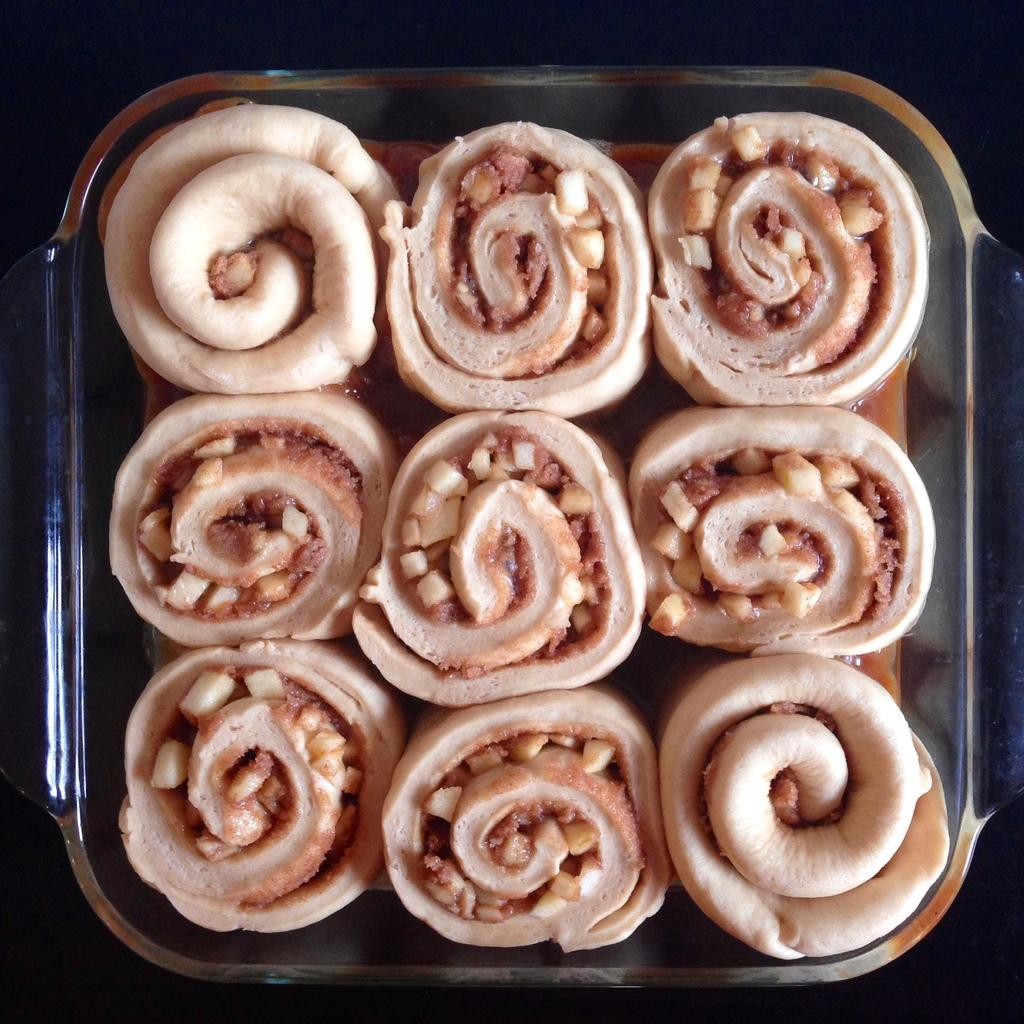What type of food is visible in the image? There are rolls in the image. How are the rolls arranged in the image? The rolls are placed in a bowl. What type of oatmeal is being prepared by the father for the boys in the image? There is no oatmeal, father, or boys present in the image; it only features rolls placed in a bowl. 